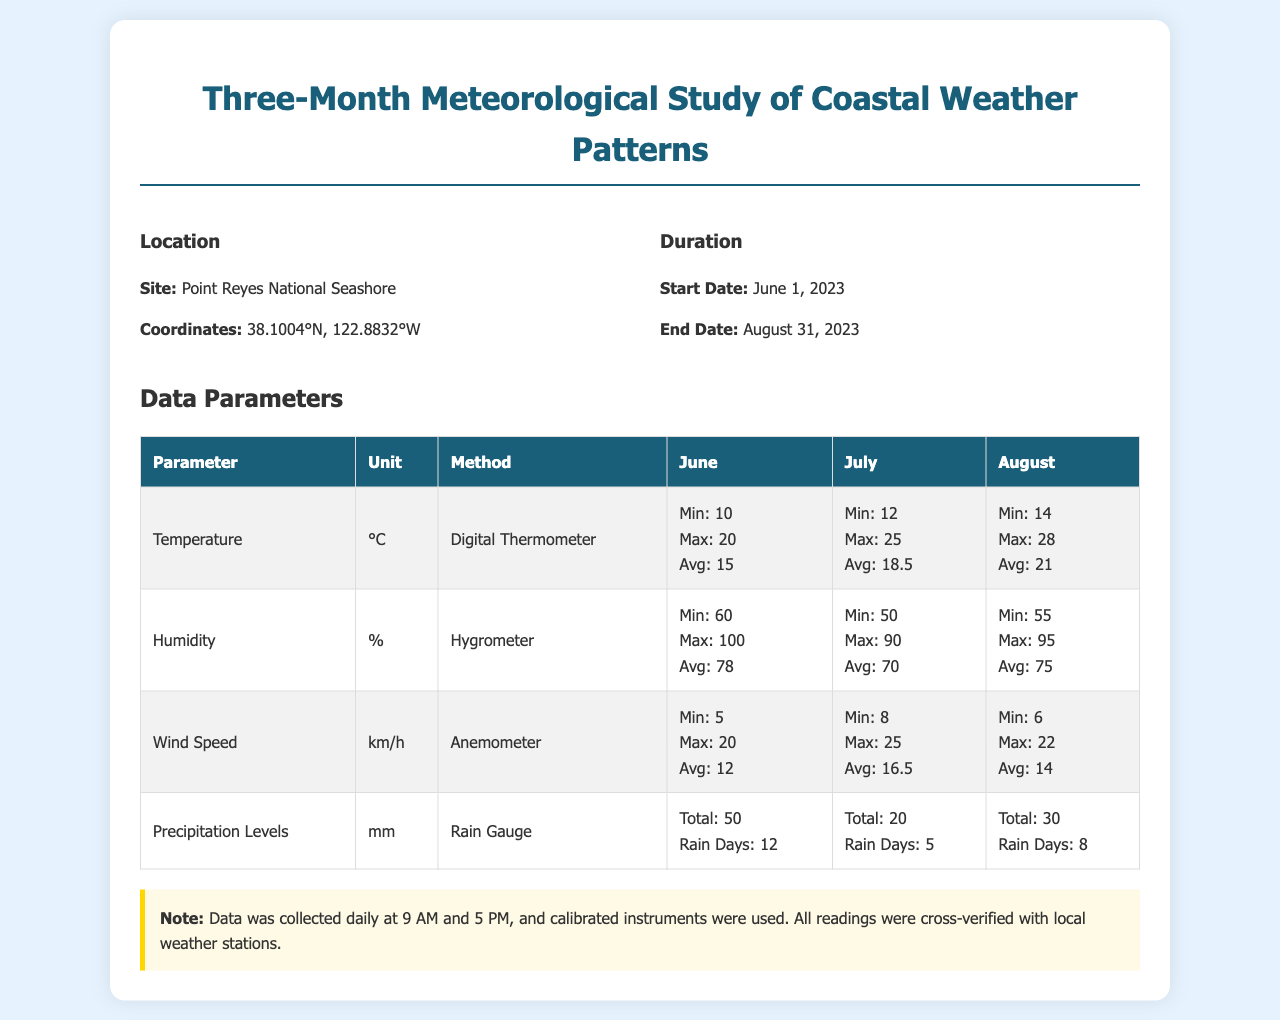what is the site of the study? The site of the study is explicitly mentioned in the document as Point Reyes National Seashore.
Answer: Point Reyes National Seashore what are the coordinates of the study location? The coordinates provided in the document indicate the specific geographic location of the study site.
Answer: 38.1004°N, 122.8832°W what was the maximum temperature recorded in July? The document lists the maximum temperature for July under the temperature parameter.
Answer: 25 what was the average humidity in August? The average humidity for August is specified under the humidity parameter in the document.
Answer: 75 how many rain days were recorded in June? The document states the number of rain days recorded in June under the precipitation levels parameter.
Answer: 12 what is the method used for measuring wind speed? The document provides the method used to measure wind speed directly under the wind speed parameter.
Answer: Anemometer what was the total precipitation in July? Total precipitation for July is noted under the precipitation levels section in the document.
Answer: 20 which month had the highest average temperature? To find this, we can compare the average temperatures across the three months listed in the table.
Answer: August what is the start date of the study? The start date of the study is provided in the duration section of the document.
Answer: June 1, 2023 how often was the data collected? The document notes the frequency of data collection in the note section.
Answer: Daily at 9 AM and 5 PM 